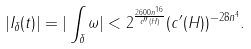<formula> <loc_0><loc_0><loc_500><loc_500>| I _ { \delta } ( t ) | = | \int _ { \delta } \omega | < 2 ^ { \frac { 2 6 0 0 n ^ { 1 6 } } { c ^ { \prime \prime } ( H ) } } ( c ^ { \prime } ( H ) ) ^ { - 2 8 n ^ { 4 } } .</formula> 